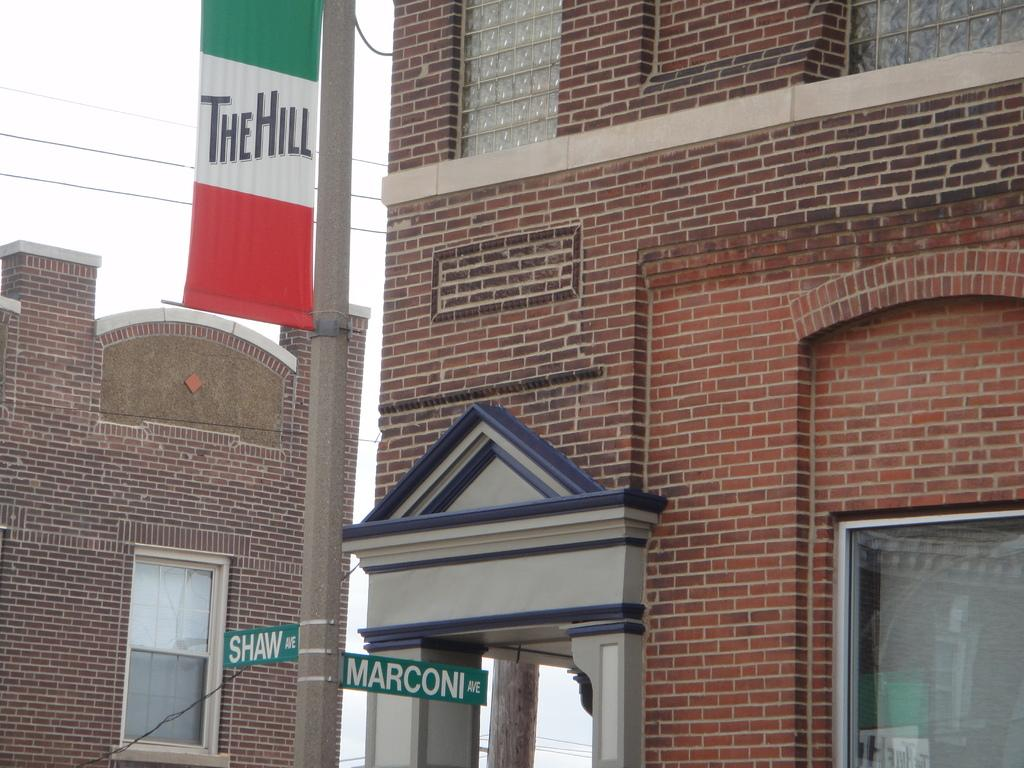What type of structures can be seen in the image? There are buildings in the image. What else is visible in the image besides the buildings? Cables, a banner, and name boards on poles are visible in the image. What is the background of the image? The sky is visible in the background of the image. What type of fruit is being sold at the chance encounter with the pear vendor in the image? There is no mention of a chance encounter or a pear vendor in the image; it features buildings, cables, a banner, and name boards on poles. Can you tell me how many bags of popcorn are visible in the image? There is no popcorn present in the image. 